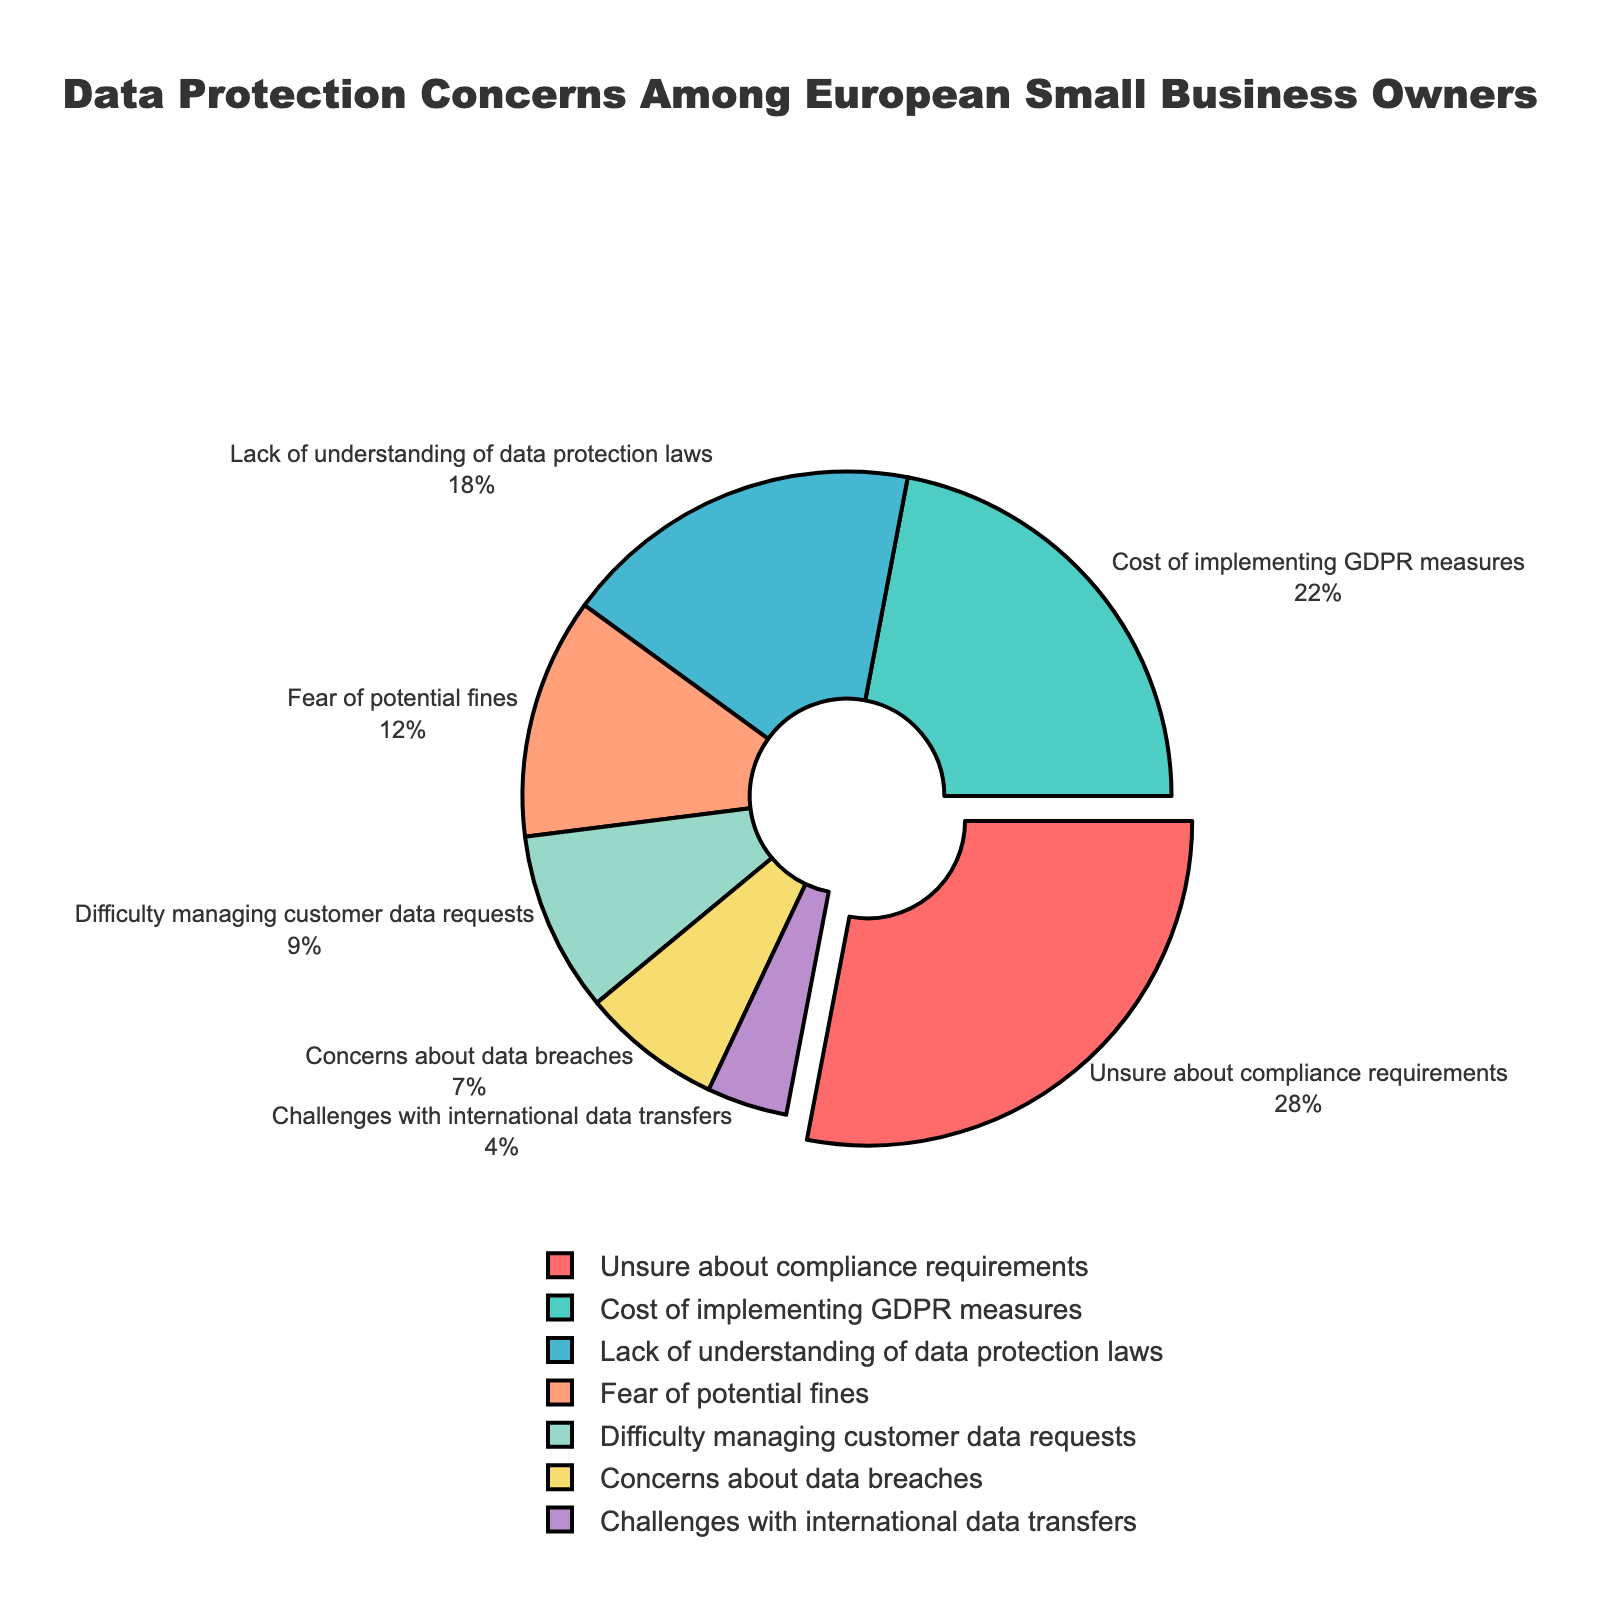What is the most common data protection concern among European small business owners? The figure shows several concerns with percentages. "Unsure about compliance requirements" has the highest percentage at 28%.
Answer: Unsure about compliance requirements Which concern is the least common? The figure has several concerns listed with their respective percentages. "Challenges with international data transfers" has the lowest percentage at 4%.
Answer: Challenges with international data transfers How much higher is the percentage of "Unsure about compliance requirements" compared to "Cost of implementing GDPR measures"? "Unsure about compliance requirements" is 28% and "Cost of implementing GDPR measures" is 22%. The difference is 28% - 22%.
Answer: 6% What is the combined percentage of concerns related to understanding and managing data (i.e., "Lack of understanding of data protection laws" and "Difficulty managing customer data requests")? "Lack of understanding of data protection laws" is 18% and "Difficulty managing customer data requests" is 9%. Their sum is 18% + 9%.
Answer: 27% How does the concern of "Fear of potential fines" compare to "Concerns about data breaches"? "Fear of potential fines" is 12% and "Concerns about data breaches" is 7%. Comparison can show 12% is greater than 7%.
Answer: Fear of potential fines is 5% higher Which segments are colored in red and green, respectively? The visual chart uses colors. The red segment represents "Unsure about compliance requirements," and the green segment represents "Cost of implementing GDPR measures."
Answer: Unsure about compliance requirements and Cost of implementing GDPR measures What percentage of concerns are related to compliance (i.e., "Unsure about compliance requirements" and "Lack of understanding of data protection laws")? "Unsure about compliance requirements" is 28% and "Lack of understanding of data protection laws" is 18%. Their combined percentage is 28% + 18%.
Answer: 46% Which concern has a larger percentage: "Difficulty managing customer data requests" or "Concerns about data breaches"? "Difficulty managing customer data requests" has 9%, while "Concerns about data breaches" has 7%. The percentage for the former is larger.
Answer: Difficulty managing customer data requests What is the total percentage of concerns that have to do with data security (i.e., "Concerns about data breaches" and "Challenges with international data transfers")? "Concerns about data breaches" is 7% and "Challenges with international data transfers" is 4%. Adding them together gives 7% + 4%.
Answer: 11% What percentage of concerns are related to costs (i.e., "Cost of implementing GDPR measures" and "Fear of potential fines")? "Cost of implementing GDPR measures" is 22% and "Fear of potential fines" is 12%. Combined, it would be 22% + 12%.
Answer: 34% 